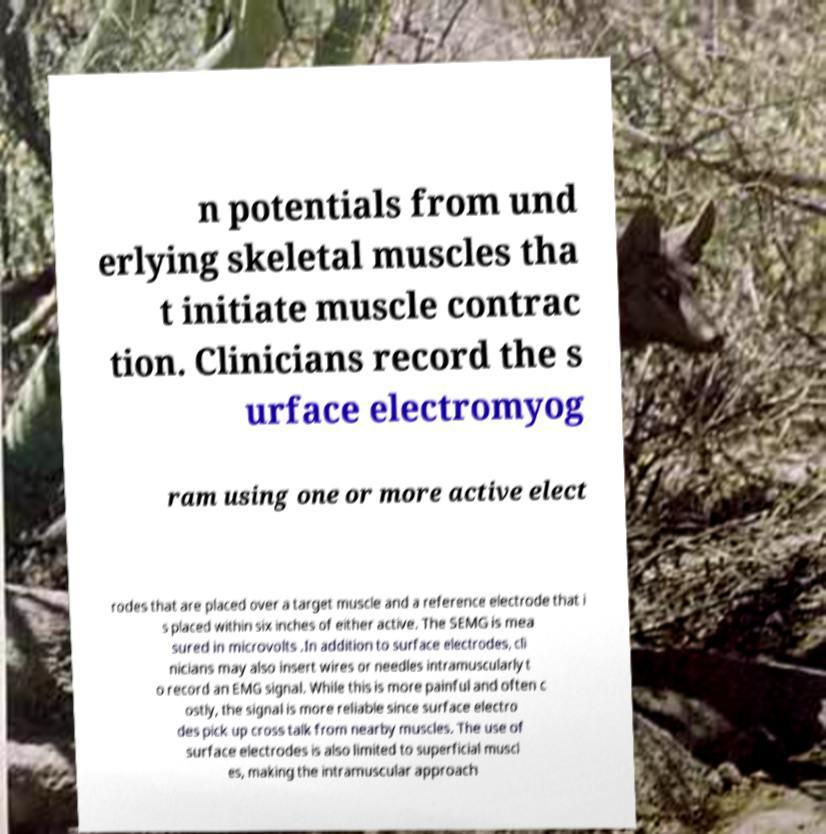Can you accurately transcribe the text from the provided image for me? n potentials from und erlying skeletal muscles tha t initiate muscle contrac tion. Clinicians record the s urface electromyog ram using one or more active elect rodes that are placed over a target muscle and a reference electrode that i s placed within six inches of either active. The SEMG is mea sured in microvolts .In addition to surface electrodes, cli nicians may also insert wires or needles intramuscularly t o record an EMG signal. While this is more painful and often c ostly, the signal is more reliable since surface electro des pick up cross talk from nearby muscles. The use of surface electrodes is also limited to superficial muscl es, making the intramuscular approach 